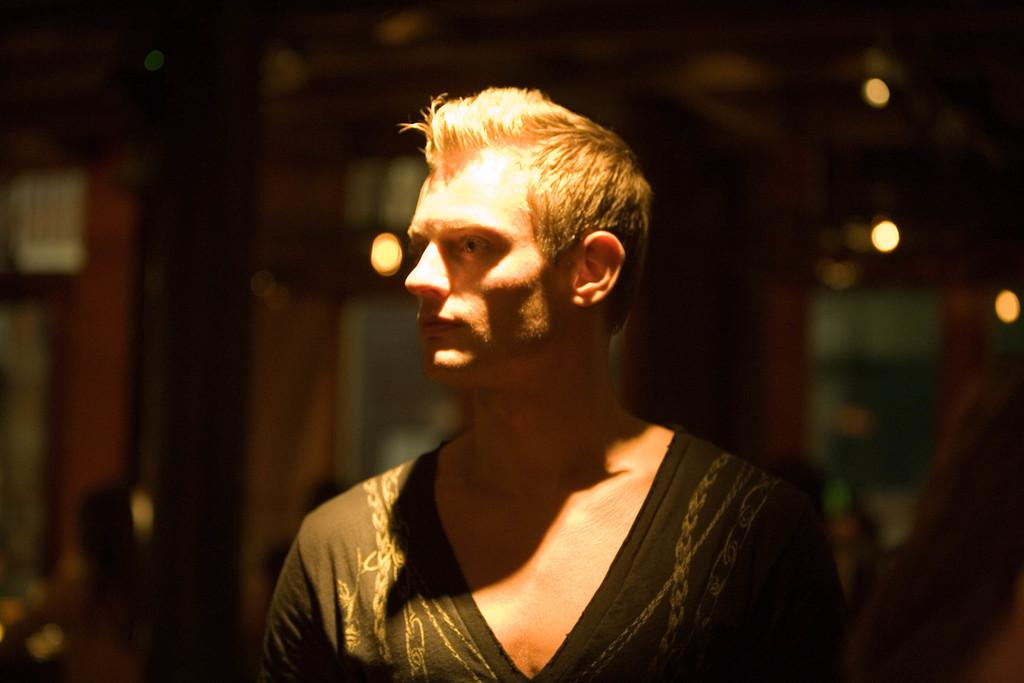Who is the main subject in the image? There is a man in the image. What is the man wearing? The man is wearing a black dress. Can you describe any additional features of the man? There is a light on the man. What is the condition of the background in the image? The background of the image is blurred. What else can be seen in the background? There are lights visible in the background. What type of meal is the man preparing in the image? There is no indication in the image that the man is preparing a meal, as the focus is on his clothing and the light on him. 